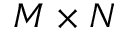Convert formula to latex. <formula><loc_0><loc_0><loc_500><loc_500>M \times N</formula> 